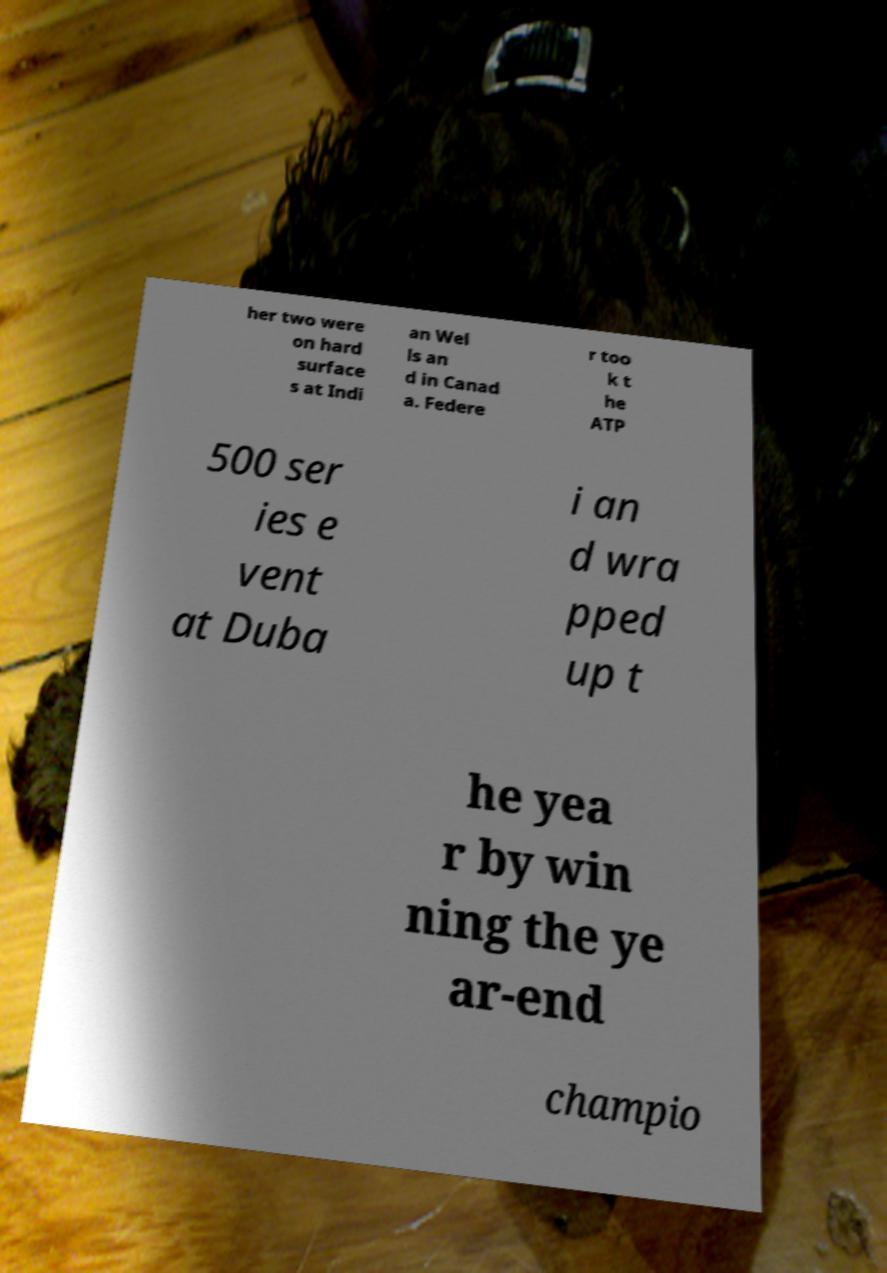Please read and relay the text visible in this image. What does it say? her two were on hard surface s at Indi an Wel ls an d in Canad a. Federe r too k t he ATP 500 ser ies e vent at Duba i an d wra pped up t he yea r by win ning the ye ar-end champio 